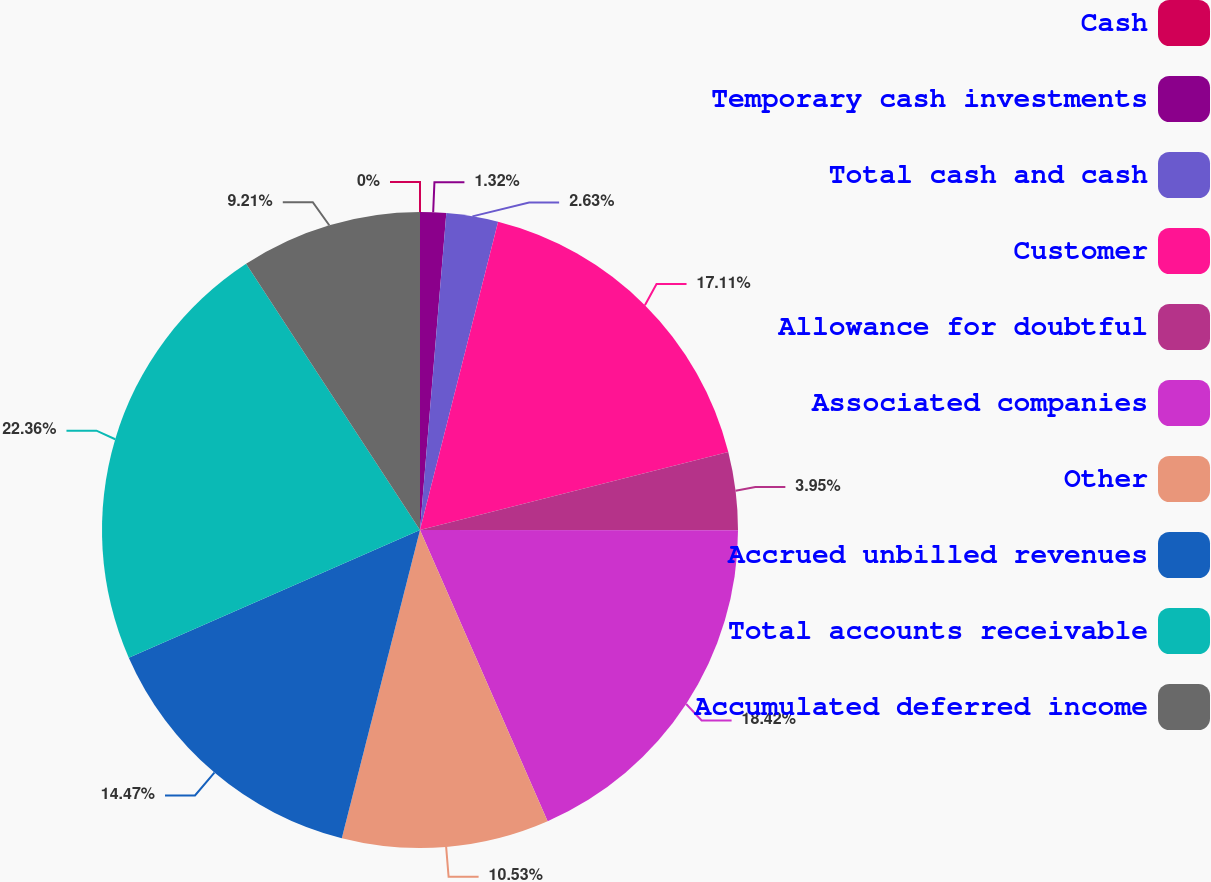Convert chart to OTSL. <chart><loc_0><loc_0><loc_500><loc_500><pie_chart><fcel>Cash<fcel>Temporary cash investments<fcel>Total cash and cash<fcel>Customer<fcel>Allowance for doubtful<fcel>Associated companies<fcel>Other<fcel>Accrued unbilled revenues<fcel>Total accounts receivable<fcel>Accumulated deferred income<nl><fcel>0.0%<fcel>1.32%<fcel>2.63%<fcel>17.11%<fcel>3.95%<fcel>18.42%<fcel>10.53%<fcel>14.47%<fcel>22.37%<fcel>9.21%<nl></chart> 